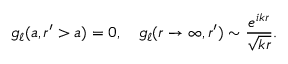Convert formula to latex. <formula><loc_0><loc_0><loc_500><loc_500>g _ { \ell } ( a , r ^ { \prime } > a ) = 0 , \quad g _ { \ell } ( r \rightarrow \infty , r ^ { \prime } ) \sim \frac { e ^ { i k r } } { \sqrt { k r } } .</formula> 